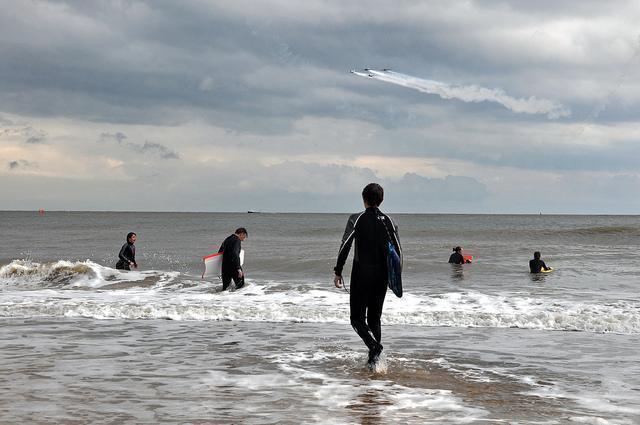How many people?
Give a very brief answer. 5. 